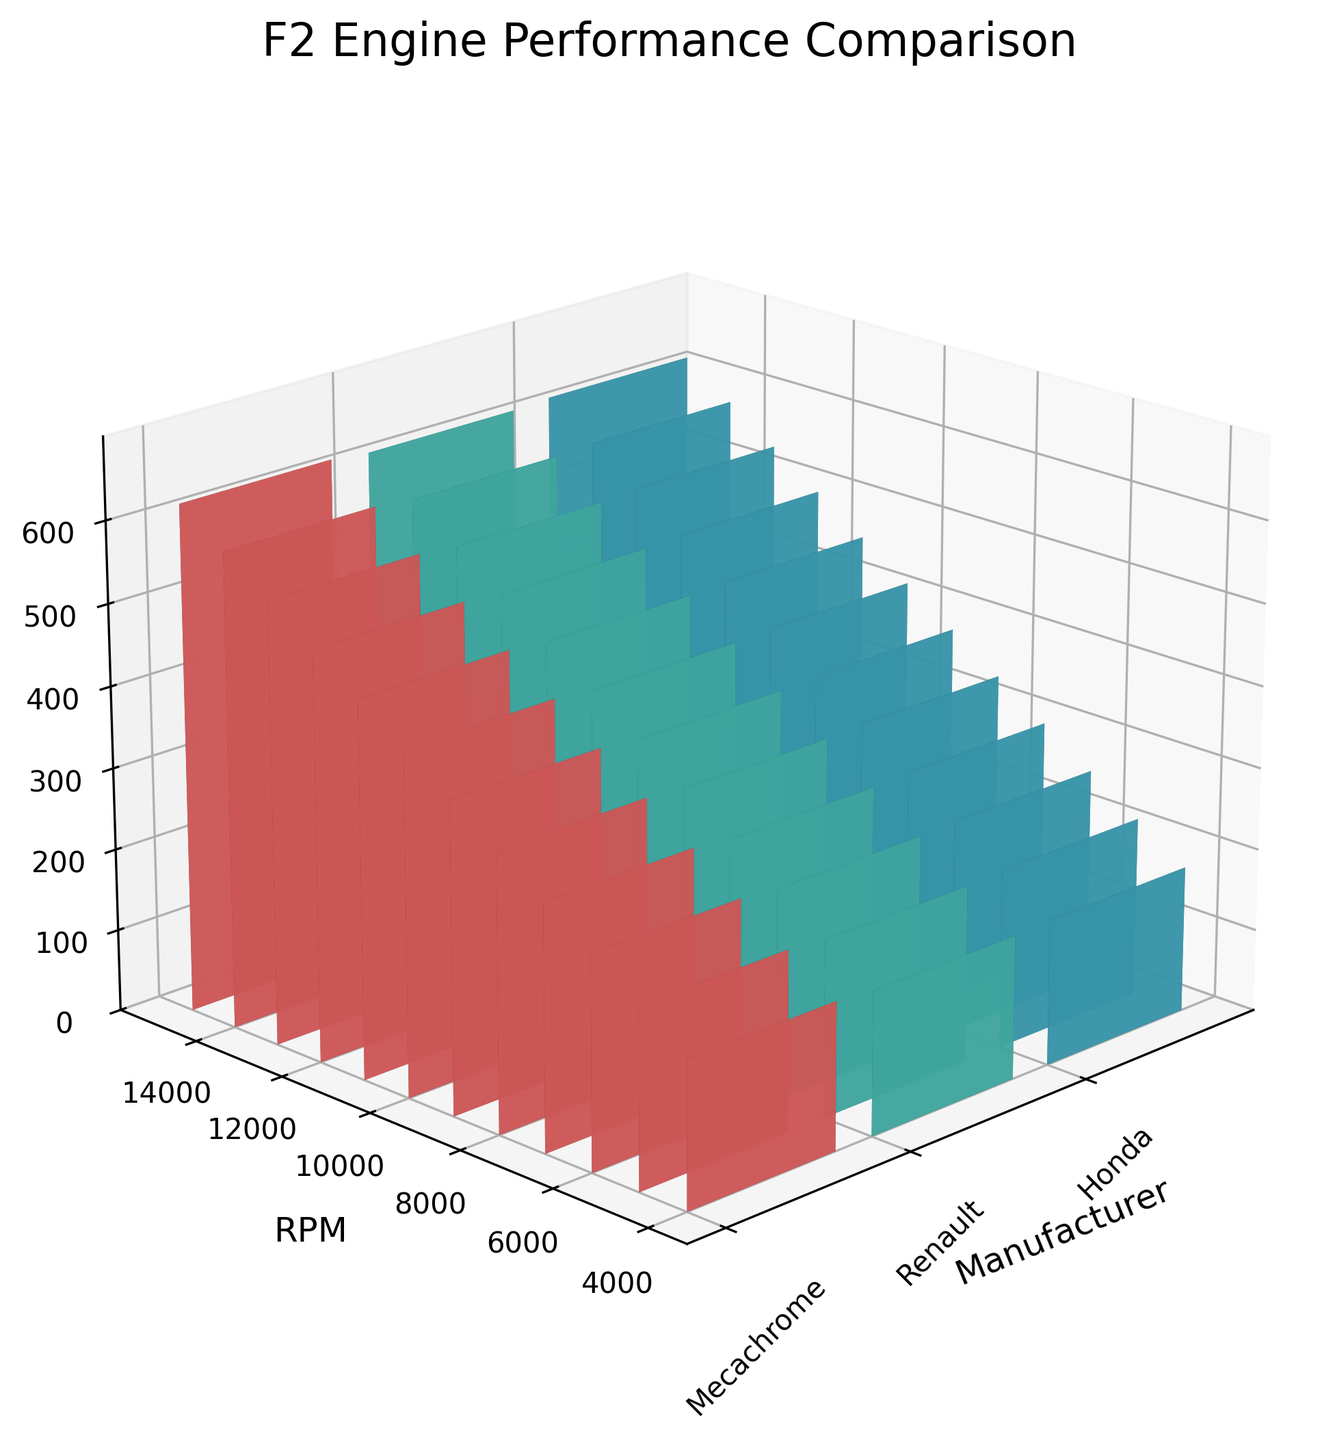what is the title of the plot? The title is usually displayed at the top of the plot. In this case, it reads 'F2 Engine Performance Comparison'.
Answer: F2 Engine Performance Comparison How many manufacturers are compared in the plot? Count the number of labels on the x-axis, where each label represents a different manufacturer. In this case, there are three: Mecachrome, Renault, and Honda.
Answer: 3 What is the power output for Mecachrome at 10,000 RPM? Locate the bar for Mecachrome (first set of bars on the left) and the height at 10,000 RPM on the y-axis. The z-axis value for this bar is around 4.20, which translates to 420 HP when multiplied by 100.
Answer: 420 HP How does the power output of Renault at 8,000 RPM compare to Honda at the same RPM? Find the bars for Renault (middle set) and Honda (right set) at 8,000 RPM. Compare their heights. Renault has a value of 3.35 (335 HP) while Honda has 3.38 (338 HP), so Honda has a slightly higher power output.
Answer: Honda has a slightly higher power output What is the difference in power output between Mecachrome and Renault at 14,000 RPM? Identify the bars for Mecachrome and Renault at 14,000 RPM, then calculate their difference. Mecachrome is 5.80 (580 HP), and Renault is 5.75 (575 HP). The difference is 580 - 575 = 5 HP.
Answer: 5 HP Which manufacturer demonstrates the highest power output at any RPM? Check the z-axis values for all manufacturers across RPMs and identify the highest bar. Mecachrome at 15,000 RPM has a value of 6.20 (620 HP), which is the highest.
Answer: Mecachrome What range of RPM is covered in the plot? Look at the y-axis, which shows the RPM values. It ranges from 4,000 RPM to 15,000 RPM.
Answer: 4,000 to 15,000 RPM What is the average power output of Honda across all RPM values? Sum the power outputs for Honda at each RPM value and divide by the number of RPM values (12). [(178 + 218 + 258 + 298 + 338 + 378 + 418 + 458 + 498 + 538 + 578 + 618) / 12] = 4280 / 12 = 356.67 HP.
Answer: 356.67 HP 